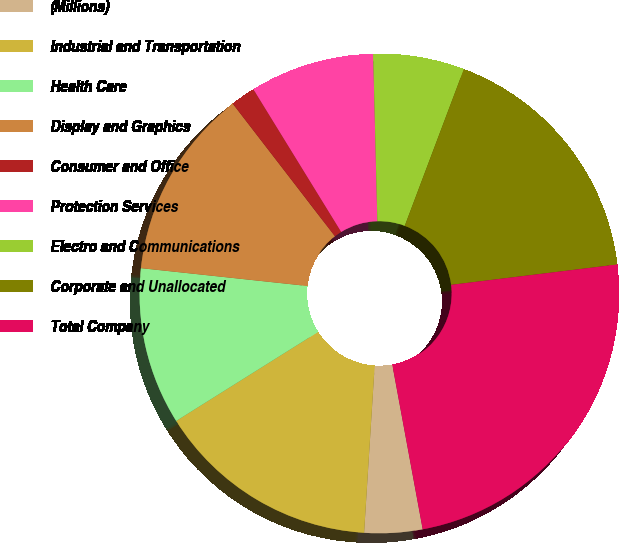Convert chart to OTSL. <chart><loc_0><loc_0><loc_500><loc_500><pie_chart><fcel>(Millions)<fcel>Industrial and Transportation<fcel>Health Care<fcel>Display and Graphics<fcel>Consumer and Office<fcel>Protection Services<fcel>Electro and Communications<fcel>Corporate and Unallocated<fcel>Total Company<nl><fcel>3.91%<fcel>15.08%<fcel>10.61%<fcel>12.85%<fcel>1.67%<fcel>8.38%<fcel>6.14%<fcel>17.32%<fcel>24.03%<nl></chart> 